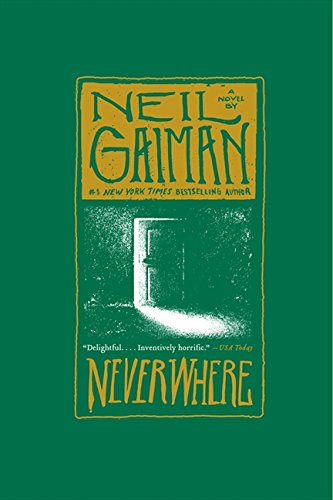Could you describe the significance of the door depicted on the cover? The door on the cover of 'Neverwhere: A Novel' symbolizes the entrance to a hidden and parallel version of London, serving as a gateway to the mysterious and daunting world beneath the city's surface. 